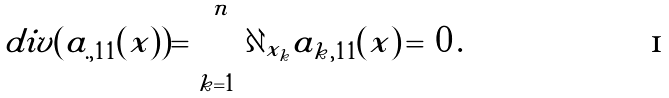Convert formula to latex. <formula><loc_0><loc_0><loc_500><loc_500>d i v ( a _ { . , 1 1 } ( x ) ) = \sum _ { k = 1 } ^ { n } \partial _ { x _ { k } } a _ { k , 1 1 } ( x ) \, = \, 0 \, .</formula> 